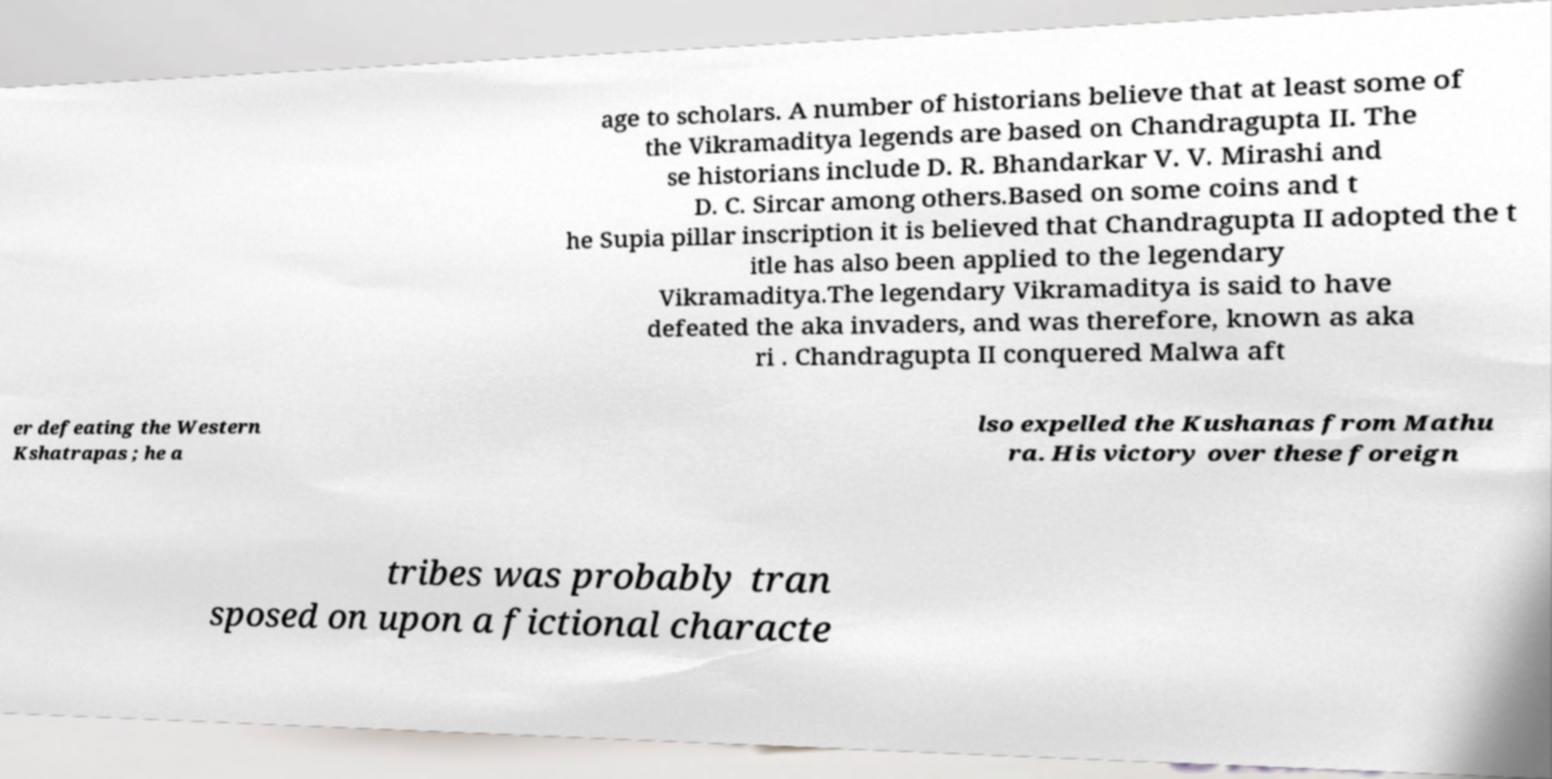Could you assist in decoding the text presented in this image and type it out clearly? age to scholars. A number of historians believe that at least some of the Vikramaditya legends are based on Chandragupta II. The se historians include D. R. Bhandarkar V. V. Mirashi and D. C. Sircar among others.Based on some coins and t he Supia pillar inscription it is believed that Chandragupta II adopted the t itle has also been applied to the legendary Vikramaditya.The legendary Vikramaditya is said to have defeated the aka invaders, and was therefore, known as aka ri . Chandragupta II conquered Malwa aft er defeating the Western Kshatrapas ; he a lso expelled the Kushanas from Mathu ra. His victory over these foreign tribes was probably tran sposed on upon a fictional characte 